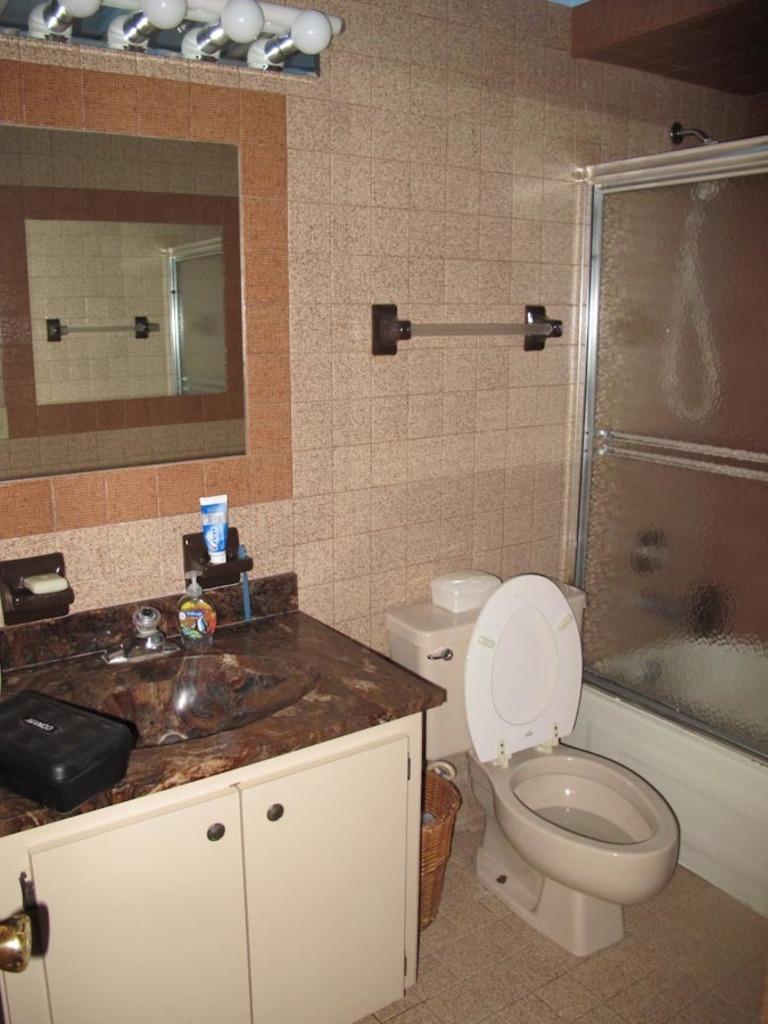How would you summarize this image in a sentence or two? In this image, we can see sink with tap, cupboard, dustbin, com board and few objects. Here we can see the wall, mirror, rod and bulbs. At the bottom, there is a floor. On the right side of the image, we can see the glass object. Through the glass we can see bathtub and few things. In the mirror, we can see some reflections. 